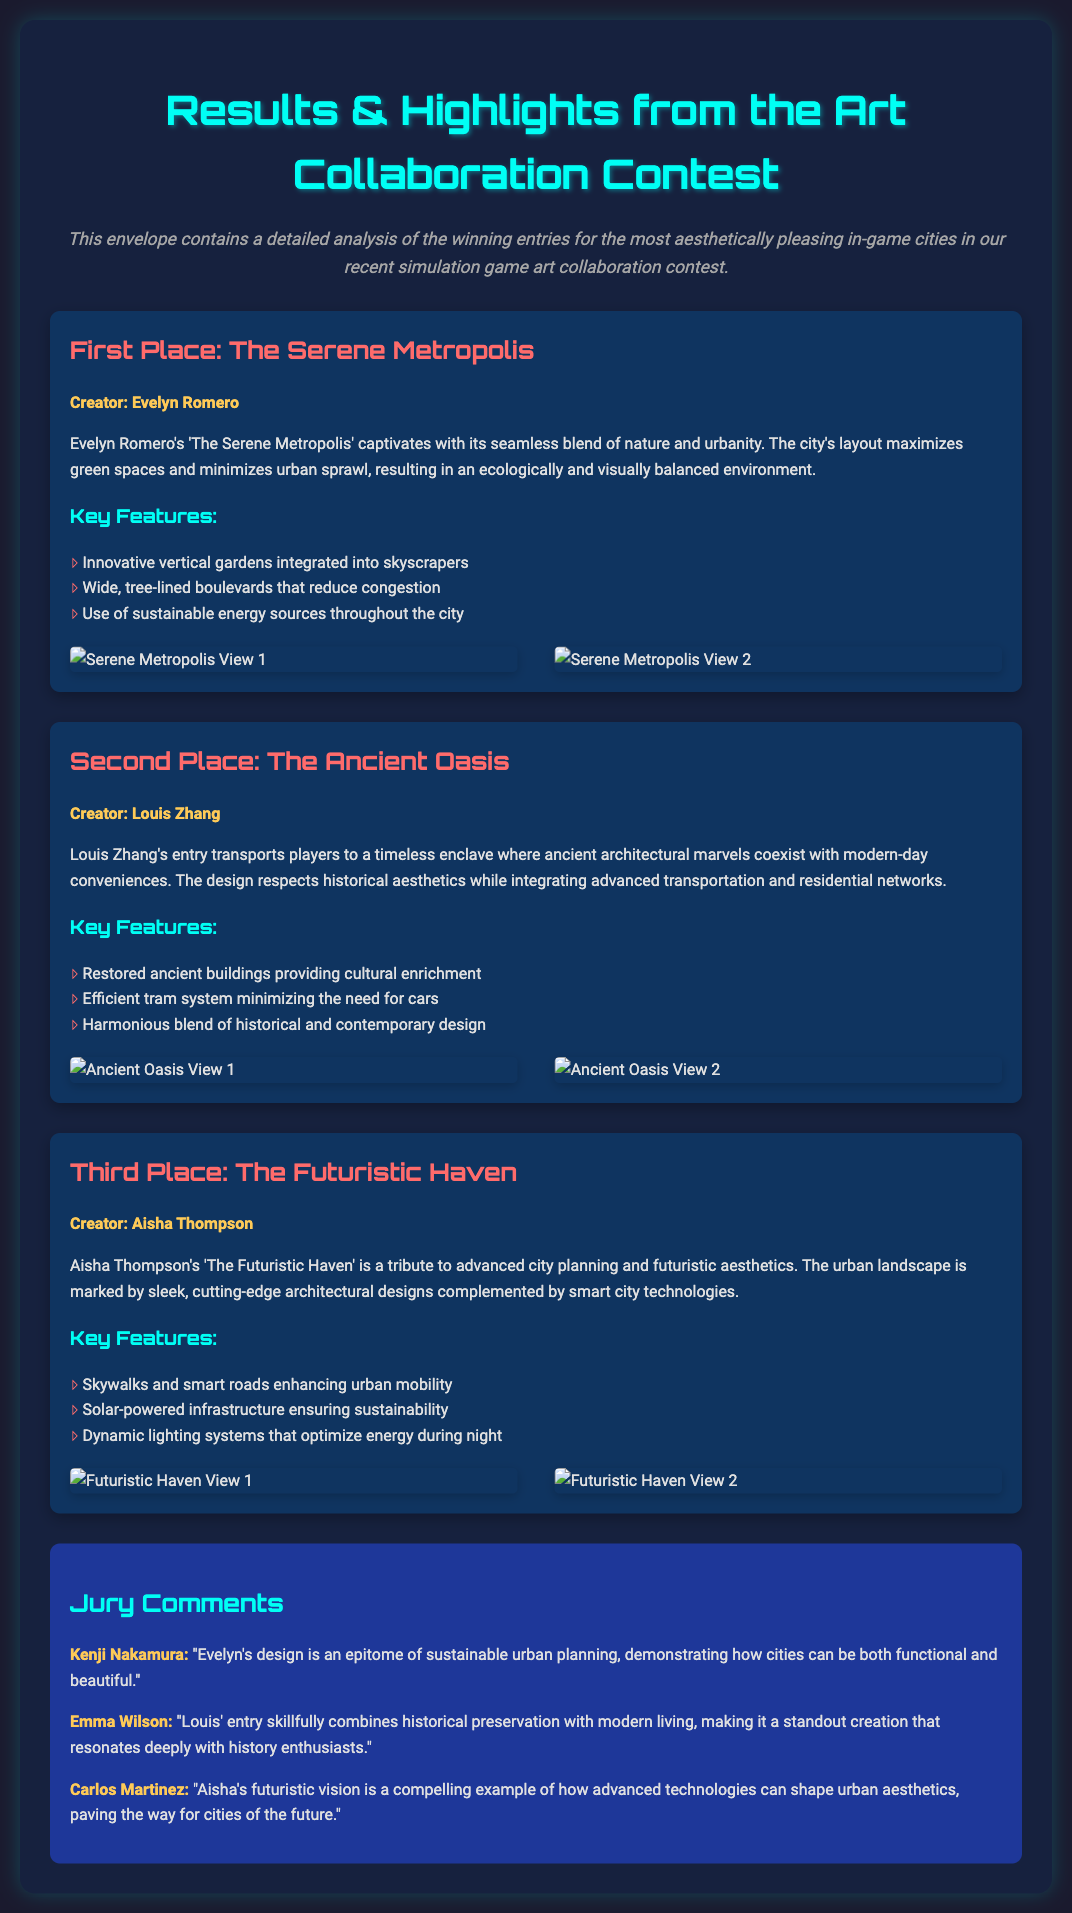What is the title of the first place entry? The title of the first place entry is provided under the "First Place" section of the document, which states "The Serene Metropolis."
Answer: The Serene Metropolis Who is the creator of the second place entry? The creator of the second place entry is mentioned in the "Second Place" section, informing us that it is Louis Zhang.
Answer: Louis Zhang What is a key feature of "The Futuristic Haven"? The document lists the key features for each entry, and one of them for "The Futuristic Haven" is "Skywalks and smart roads enhancing urban mobility."
Answer: Skywalks and smart roads enhancing urban mobility Which entry has "ancient architectural marvels"? The phrase "ancient architectural marvels" is used in the description for the second place entry, which is "The Ancient Oasis."
Answer: The Ancient Oasis Who gave a comment about Evelyn's design? The comment section provides insights from jurors, and Kenji Nakamura specifically commented on Evelyn's design.
Answer: Kenji Nakamura How many winning entries are detailed in the document? The document presents three entries, each providing a detailed description for the first, second, and third places.
Answer: Three What is the color of the jury comments background? The color used for the jury comments background can be found under the "jury-comments" section, which is stated to be a specific shade of blue.
Answer: #1e3799 Which entry is described as a tribute to advanced city planning? The description mentions that "The Futuristic Haven" is a tribute to advanced city planning, making it easy to identify.
Answer: The Futuristic Haven 